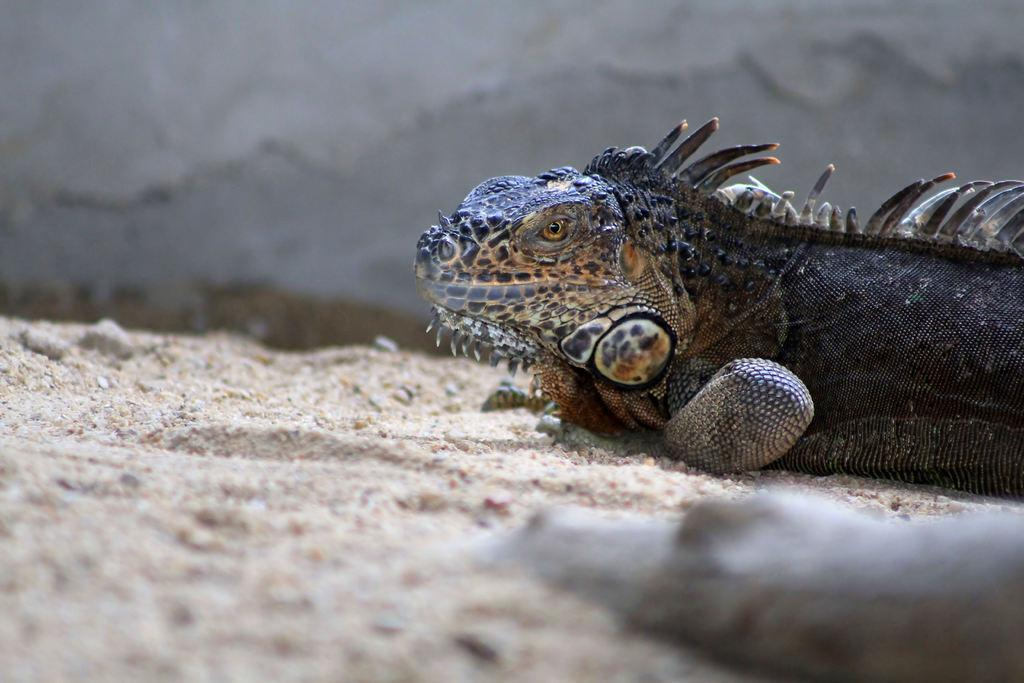What type of animal is in the image? There is a reptile in the image. Where is the reptile located in the image? The reptile is on the ground. How does the reptile compare in weight to a boy in the image? There is no boy present in the image, so it is not possible to make a comparison. 